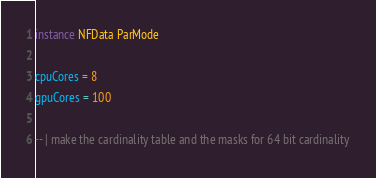Convert code to text. <code><loc_0><loc_0><loc_500><loc_500><_Haskell_>instance NFData ParMode

cpuCores = 8
gpuCores = 100

-- | make the cardinality table and the masks for 64 bit cardinality</code> 